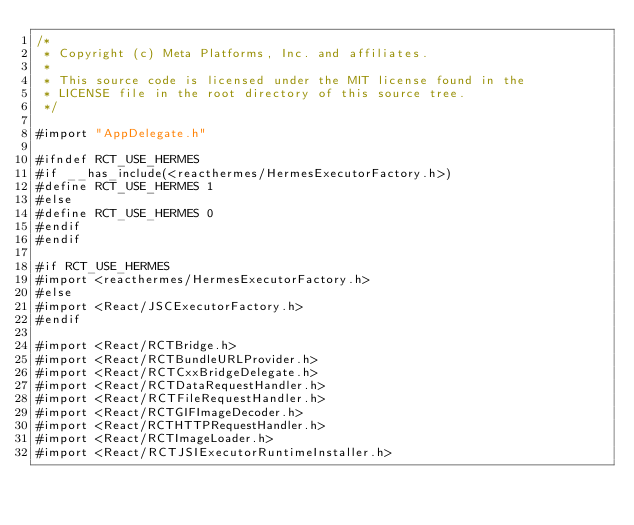<code> <loc_0><loc_0><loc_500><loc_500><_ObjectiveC_>/*
 * Copyright (c) Meta Platforms, Inc. and affiliates.
 *
 * This source code is licensed under the MIT license found in the
 * LICENSE file in the root directory of this source tree.
 */

#import "AppDelegate.h"

#ifndef RCT_USE_HERMES
#if __has_include(<reacthermes/HermesExecutorFactory.h>)
#define RCT_USE_HERMES 1
#else
#define RCT_USE_HERMES 0
#endif
#endif

#if RCT_USE_HERMES
#import <reacthermes/HermesExecutorFactory.h>
#else
#import <React/JSCExecutorFactory.h>
#endif

#import <React/RCTBridge.h>
#import <React/RCTBundleURLProvider.h>
#import <React/RCTCxxBridgeDelegate.h>
#import <React/RCTDataRequestHandler.h>
#import <React/RCTFileRequestHandler.h>
#import <React/RCTGIFImageDecoder.h>
#import <React/RCTHTTPRequestHandler.h>
#import <React/RCTImageLoader.h>
#import <React/RCTJSIExecutorRuntimeInstaller.h></code> 